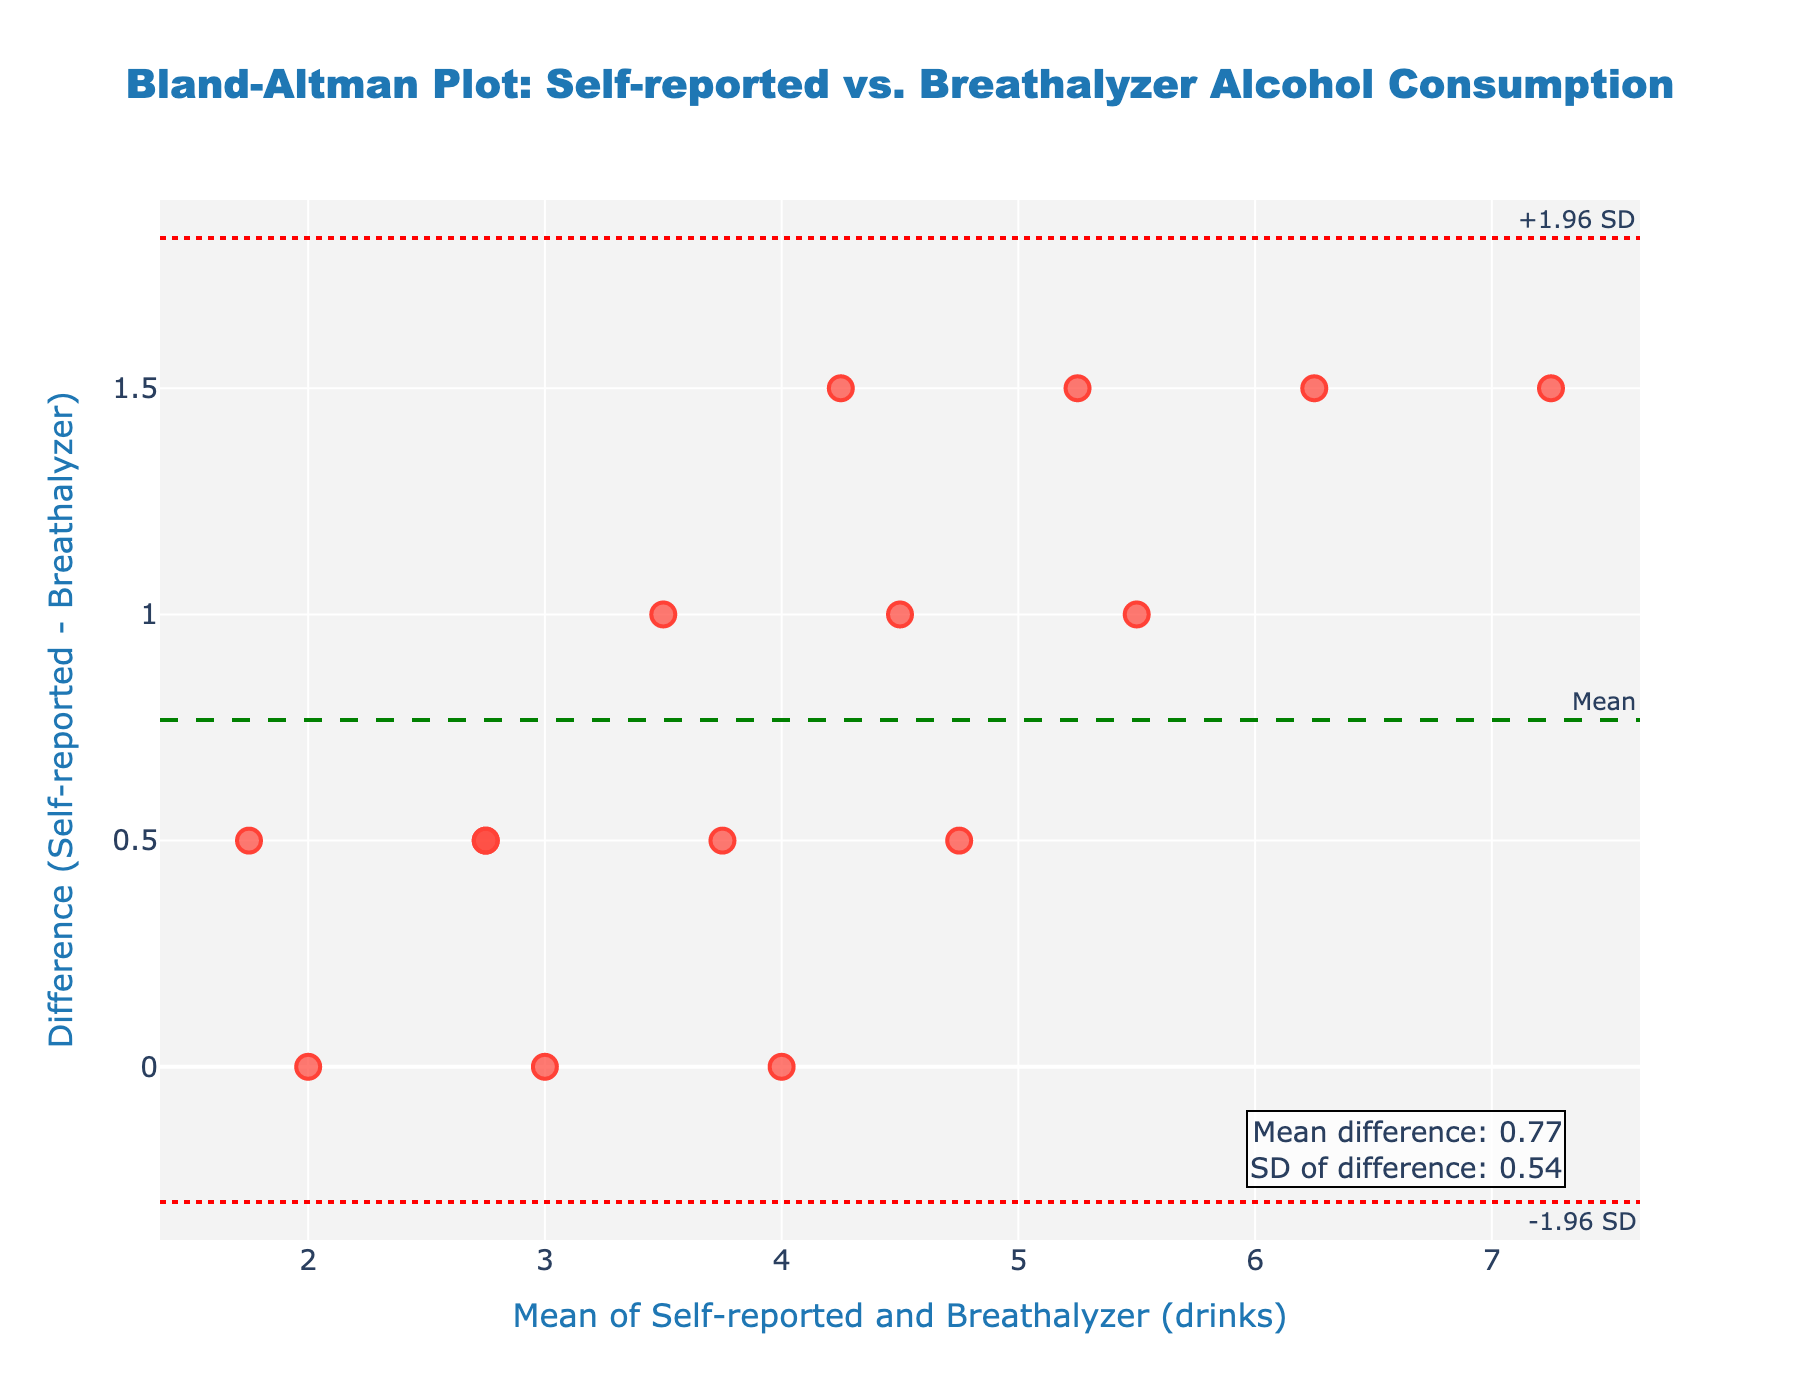What is the title of the plot? The title of the plot is displayed at the top center of the figure in a large font size. It reads "Bland-Altman Plot: Self-reported vs. Breathalyzer Alcohol Consumption".
Answer: Bland-Altman Plot: Self-reported vs. Breathalyzer Alcohol Consumption How many data points are there in the plot? Each data point corresponds to one participant's difference and mean value. By counting the number of markers in the scatter plot, we see there are 15 data points.
Answer: 15 What is the mean difference, and where is it displayed on the plot? The mean difference is shown on the figure as an annotation near the mean line. The text annotation is on the bottom right corner of the plot and states "Mean difference: -0.64".
Answer: -0.64 What are the values of the upper and lower limits of agreement (LOA)? The LOA values are indicated by the dashed red lines in the plot, with annotations on the top right and bottom right of the figure. The upper LOA is denoted as "+1.96 SD" and the lower LOA as "-1.96 SD". The text reveals the upper LOA is 1.56 and the lower LOA is -2.84.
Answer: Upper LOA: 1.56, Lower LOA: -2.84 How does the value '3' in Mean compare to the mean difference and LOA values? We locate the point with '3' on the x-axis representing the mean of self-reported and breathalyzer drinks. Observing the y-values, we find this point falls between the mean difference of -0.64 and both the LOA lines.
Answer: Between mean difference and LOA lines Which data point has the highest mean value and what is its mean? By examining the x-axis, the rightmost data point represents the highest mean value. By locating this point, we see it is labeled with a mean value of 6.065, corresponding to Matthew White.
Answer: 6.065 Are there any data points that fall outside the limits of agreement? To determine this, we inspect the scatter points in relation to the red dashed lines representing the LOA. We find that no points fall outside the area bounded by the upper LOA of 1.56 and the lower LOA of -2.84.
Answer: No What is the range of differences observed in the plot? To find the range, we identify the maximum and minimum y-values representing the difference between self-reported and breathalyzer drinks. The highest y-value is observed around 1.2, and the lowest is about -1.6. Therefore, the range is from -1.6 to 1.2.
Answer: -1.6 to 1.2 How many differences lie above the mean difference line? We count the number of points lying above the green dashed line representing the mean difference. There are 6 data points above this line.
Answer: 6 What does a negative difference indicate in this plot? The y-axis represents the difference between self-reported drinks and breathalyzer-estimated drinks. A negative difference means that the breathalyzer estimates are higher than self-reported numbers.
Answer: Breathalyzer estimates are higher 